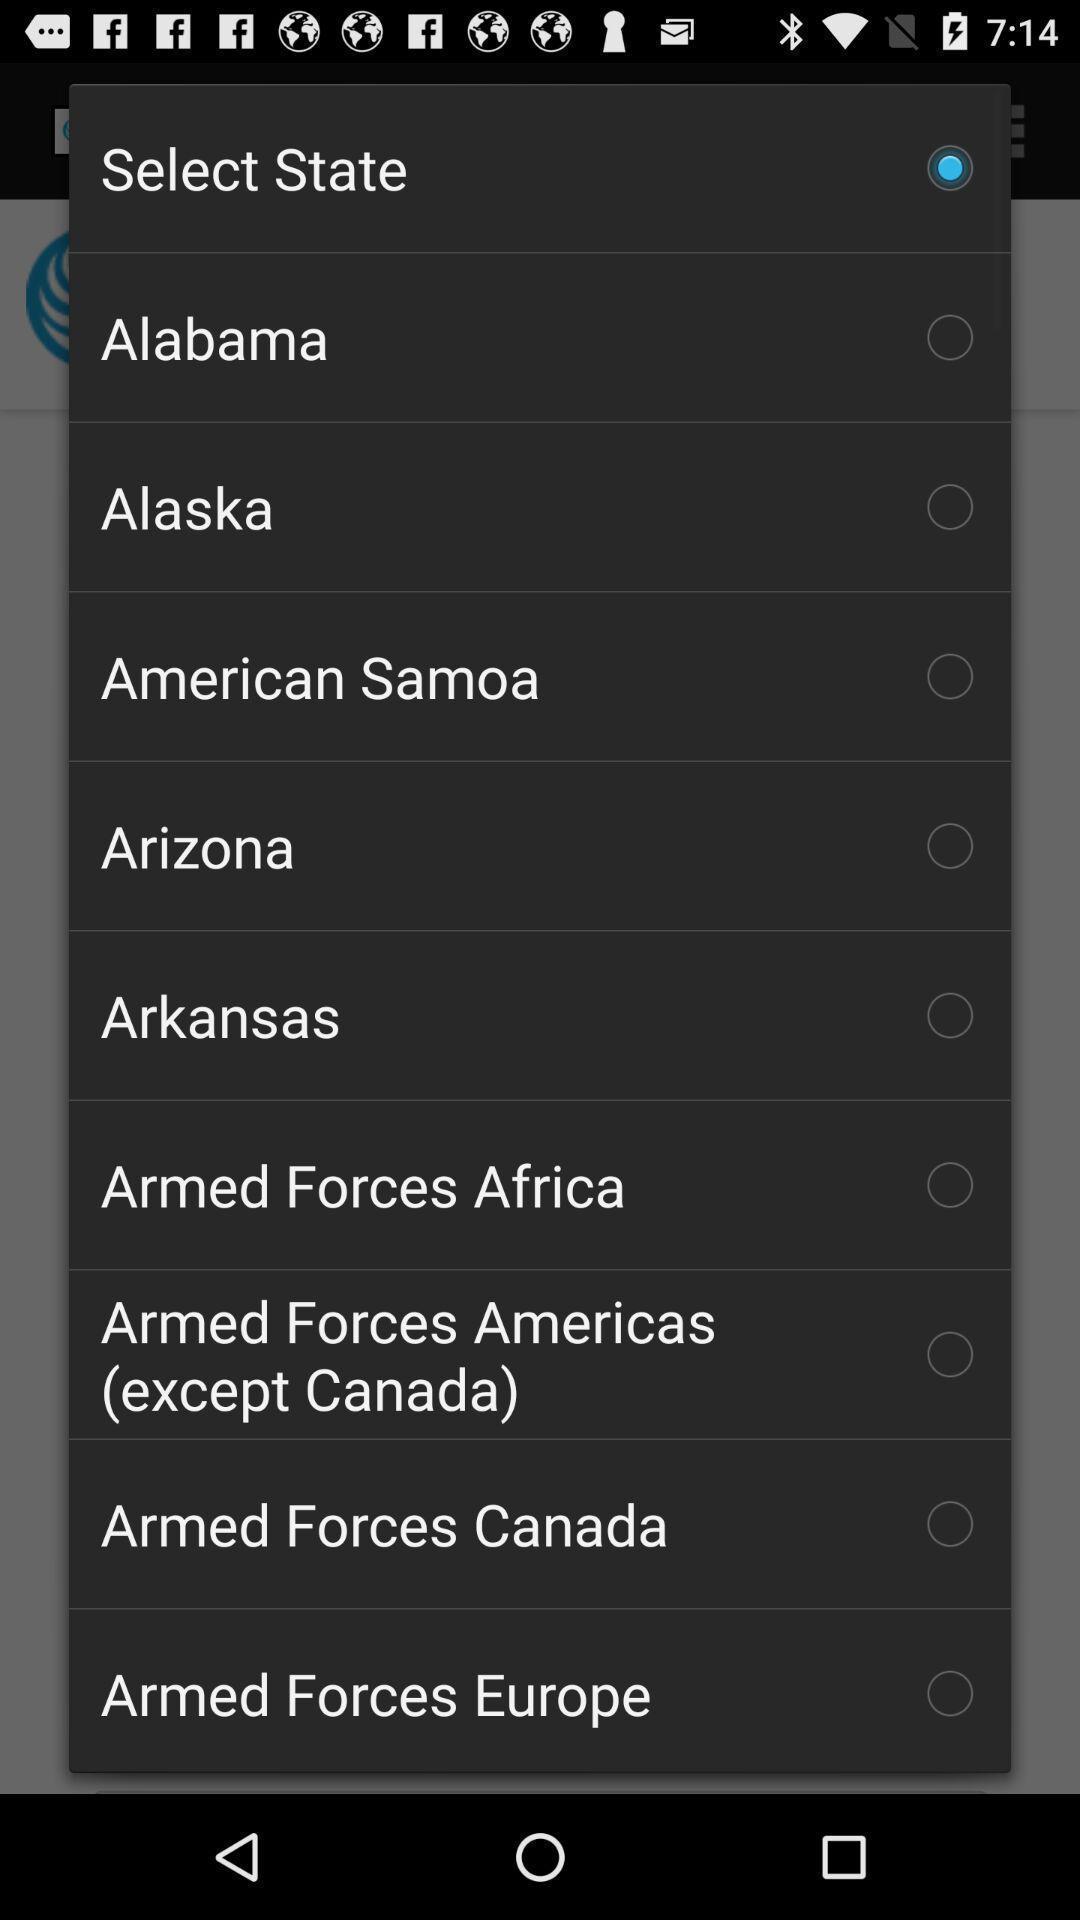Explain the elements present in this screenshot. Popup showing states to select. 